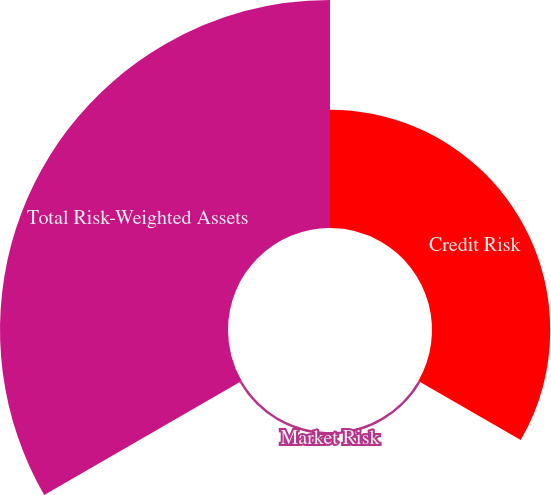Convert chart. <chart><loc_0><loc_0><loc_500><loc_500><pie_chart><fcel>Credit Risk<fcel>Market Risk<fcel>Total Risk-Weighted Assets<nl><fcel>33.91%<fcel>0.7%<fcel>65.39%<nl></chart> 